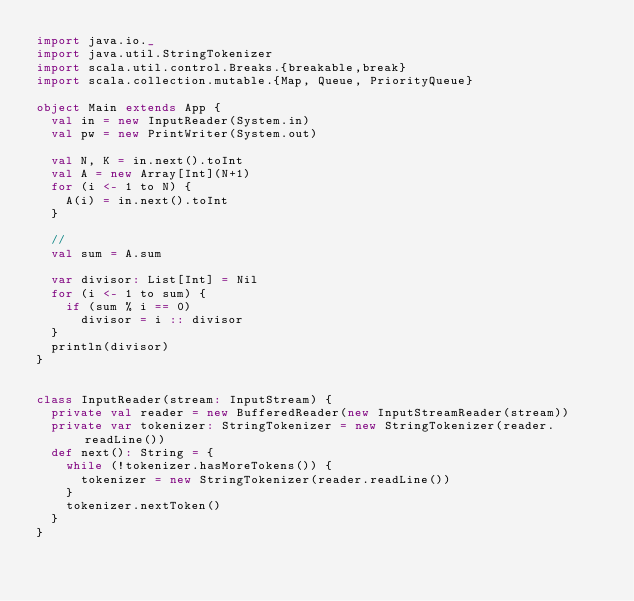<code> <loc_0><loc_0><loc_500><loc_500><_Scala_>import java.io._
import java.util.StringTokenizer
import scala.util.control.Breaks.{breakable,break}
import scala.collection.mutable.{Map, Queue, PriorityQueue}

object Main extends App {
  val in = new InputReader(System.in)
  val pw = new PrintWriter(System.out)

  val N, K = in.next().toInt
  val A = new Array[Int](N+1)
  for (i <- 1 to N) {
    A(i) = in.next().toInt
  }

  //
  val sum = A.sum

  var divisor: List[Int] = Nil
  for (i <- 1 to sum) {
    if (sum % i == 0)
      divisor = i :: divisor
  }
  println(divisor)
}


class InputReader(stream: InputStream) {
  private val reader = new BufferedReader(new InputStreamReader(stream))
  private var tokenizer: StringTokenizer = new StringTokenizer(reader.readLine())
  def next(): String = {
    while (!tokenizer.hasMoreTokens()) {
      tokenizer = new StringTokenizer(reader.readLine())
    }
    tokenizer.nextToken()
  }
}
</code> 